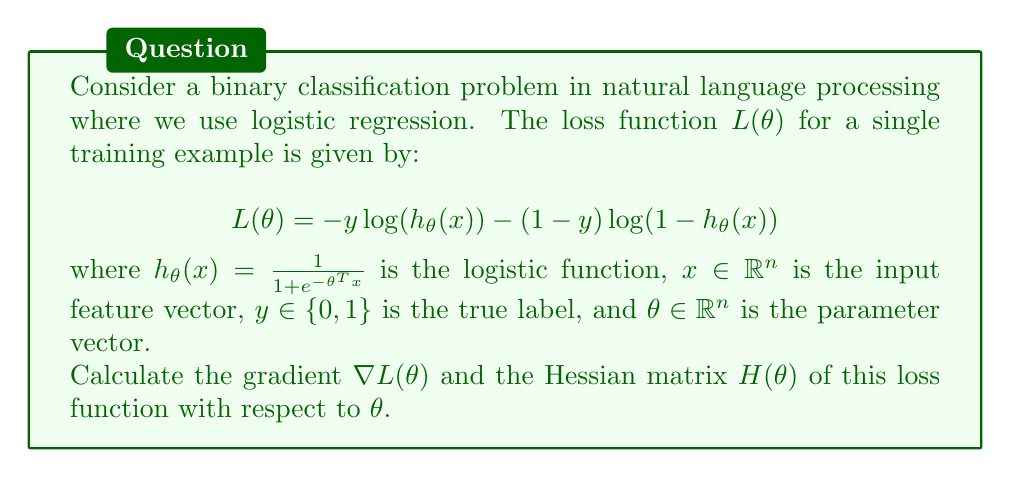Show me your answer to this math problem. To solve this problem, we'll follow these steps:

1. Calculate the gradient $\nabla L(\theta)$:
   a. Apply the chain rule to differentiate $L(\theta)$ with respect to $\theta$.
   b. Simplify the expression.

2. Calculate the Hessian matrix $H(\theta)$:
   a. Differentiate the gradient $\nabla L(\theta)$ with respect to $\theta$.
   b. Simplify the expression.

Step 1: Calculating the gradient $\nabla L(\theta)$

a. Applying the chain rule:

$$\frac{\partial L}{\partial \theta_i} = -y \frac{1}{h_\theta(x)} \frac{\partial h_\theta(x)}{\partial \theta_i} - (1-y) \frac{1}{1-h_\theta(x)} \frac{\partial (1-h_\theta(x))}{\partial \theta_i}$$

We need to calculate $\frac{\partial h_\theta(x)}{\partial \theta_i}$:

$$\frac{\partial h_\theta(x)}{\partial \theta_i} = h_\theta(x)(1-h_\theta(x))x_i$$

b. Substituting and simplifying:

$$\begin{align*}
\frac{\partial L}{\partial \theta_i} &= -y \frac{1}{h_\theta(x)} h_\theta(x)(1-h_\theta(x))x_i + (1-y) \frac{1}{1-h_\theta(x)} h_\theta(x)(1-h_\theta(x))x_i \\
&= (-y(1-h_\theta(x)) + (1-y)h_\theta(x))x_i \\
&= (h_\theta(x) - y)x_i
\end{align*}$$

Therefore, the gradient is:

$$\nabla L(\theta) = (h_\theta(x) - y)x$$

Step 2: Calculating the Hessian matrix $H(\theta)$

a. Differentiating the gradient:

$$\frac{\partial^2 L}{\partial \theta_i \partial \theta_j} = \frac{\partial}{\partial \theta_j} ((h_\theta(x) - y)x_i)$$

We need to calculate $\frac{\partial h_\theta(x)}{\partial \theta_j}$:

$$\frac{\partial h_\theta(x)}{\partial \theta_j} = h_\theta(x)(1-h_\theta(x))x_j$$

b. Substituting and simplifying:

$$\begin{align*}
\frac{\partial^2 L}{\partial \theta_i \partial \theta_j} &= x_i \frac{\partial h_\theta(x)}{\partial \theta_j} \\
&= x_i h_\theta(x)(1-h_\theta(x))x_j
\end{align*}$$

Therefore, the Hessian matrix is:

$$H(\theta) = h_\theta(x)(1-h_\theta(x))xx^T$$

where $xx^T$ is the outer product of $x$ with itself.
Answer: $\nabla L(\theta) = (h_\theta(x) - y)x$, $H(\theta) = h_\theta(x)(1-h_\theta(x))xx^T$ 